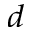Convert formula to latex. <formula><loc_0><loc_0><loc_500><loc_500>_ { d }</formula> 